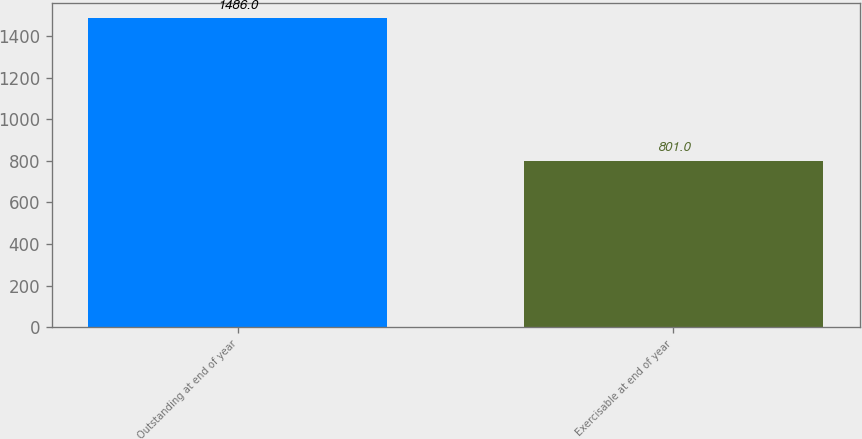Convert chart to OTSL. <chart><loc_0><loc_0><loc_500><loc_500><bar_chart><fcel>Outstanding at end of year<fcel>Exercisable at end of year<nl><fcel>1486<fcel>801<nl></chart> 